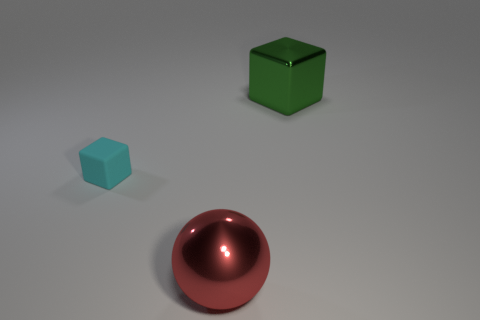Add 2 big green metallic objects. How many objects exist? 5 Add 2 large yellow rubber objects. How many large yellow rubber objects exist? 2 Subtract 0 blue blocks. How many objects are left? 3 Subtract all cubes. How many objects are left? 1 Subtract 1 spheres. How many spheres are left? 0 Subtract all yellow balls. Subtract all blue blocks. How many balls are left? 1 Subtract all red spheres. How many green cubes are left? 1 Subtract all metal objects. Subtract all yellow rubber balls. How many objects are left? 1 Add 1 cyan blocks. How many cyan blocks are left? 2 